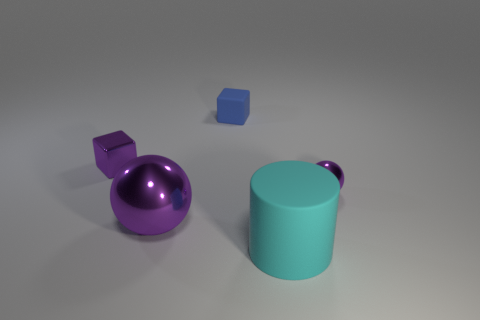What number of other metallic spheres have the same color as the big sphere?
Provide a short and direct response. 1. What size is the thing that is both on the right side of the tiny matte block and behind the big shiny thing?
Ensure brevity in your answer.  Small. Are there fewer small spheres that are on the left side of the big cyan cylinder than big cyan cylinders?
Provide a short and direct response. Yes. Are the large purple ball and the cylinder made of the same material?
Make the answer very short. No. What number of objects are tiny yellow matte things or tiny balls?
Your answer should be very brief. 1. What number of tiny red spheres have the same material as the cyan cylinder?
Your response must be concise. 0. Are there any metal things to the right of the blue object?
Your response must be concise. Yes. What material is the tiny purple block?
Ensure brevity in your answer.  Metal. Does the ball that is behind the big ball have the same color as the big metal object?
Your response must be concise. Yes. Are there any other things that have the same shape as the large cyan object?
Make the answer very short. No. 